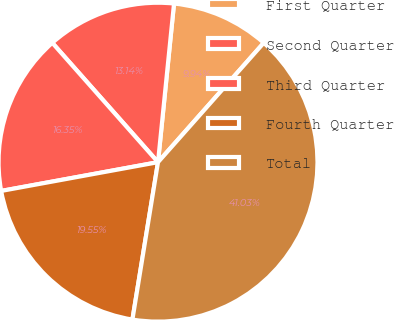Convert chart. <chart><loc_0><loc_0><loc_500><loc_500><pie_chart><fcel>First Quarter<fcel>Second Quarter<fcel>Third Quarter<fcel>Fourth Quarter<fcel>Total<nl><fcel>9.94%<fcel>13.14%<fcel>16.35%<fcel>19.55%<fcel>41.03%<nl></chart> 